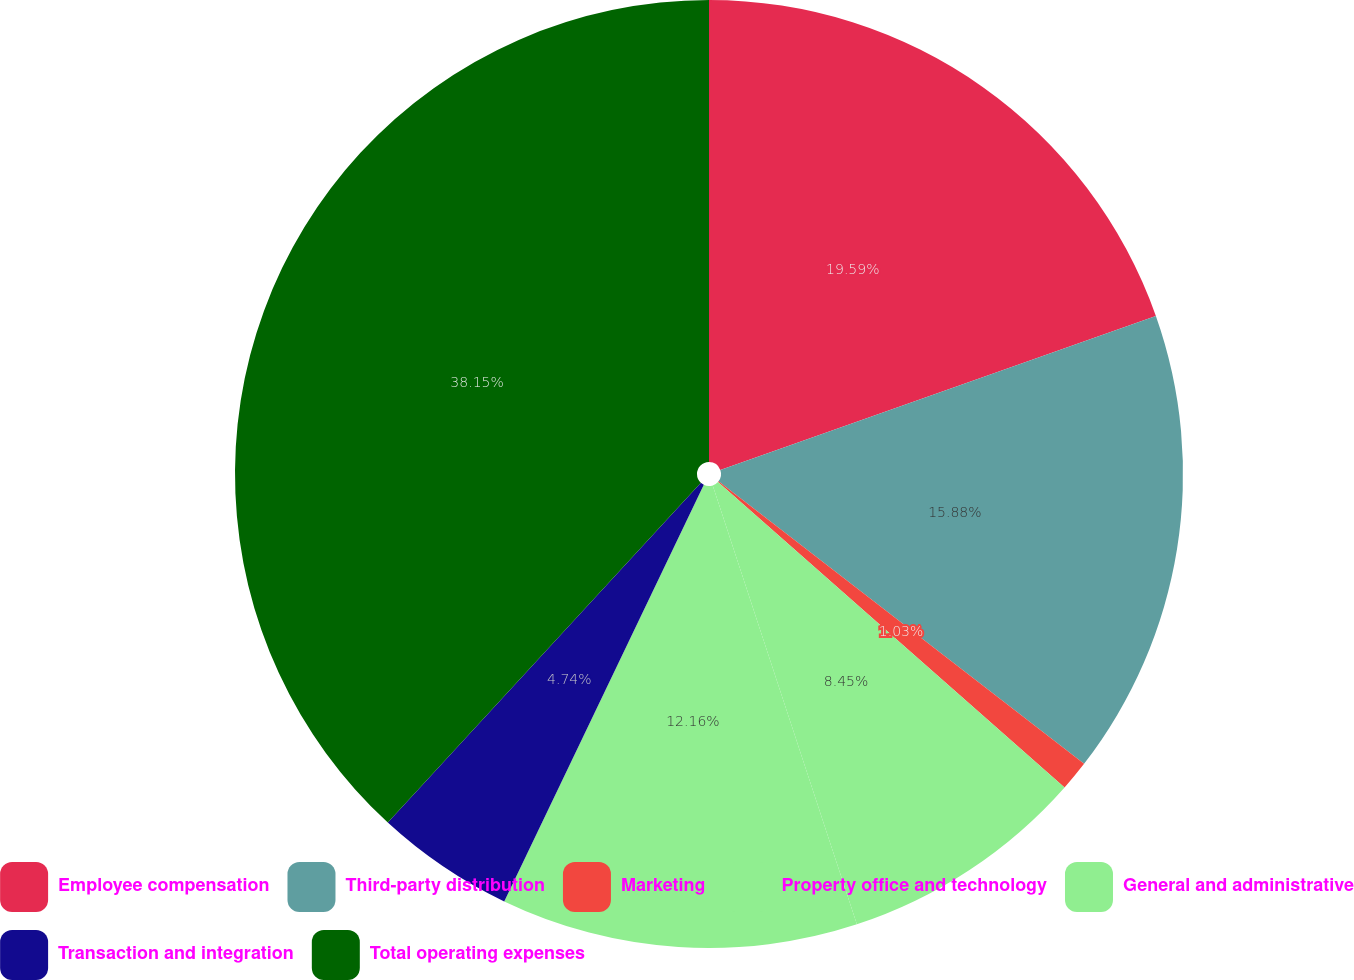<chart> <loc_0><loc_0><loc_500><loc_500><pie_chart><fcel>Employee compensation<fcel>Third-party distribution<fcel>Marketing<fcel>Property office and technology<fcel>General and administrative<fcel>Transaction and integration<fcel>Total operating expenses<nl><fcel>19.59%<fcel>15.88%<fcel>1.03%<fcel>8.45%<fcel>12.16%<fcel>4.74%<fcel>38.15%<nl></chart> 